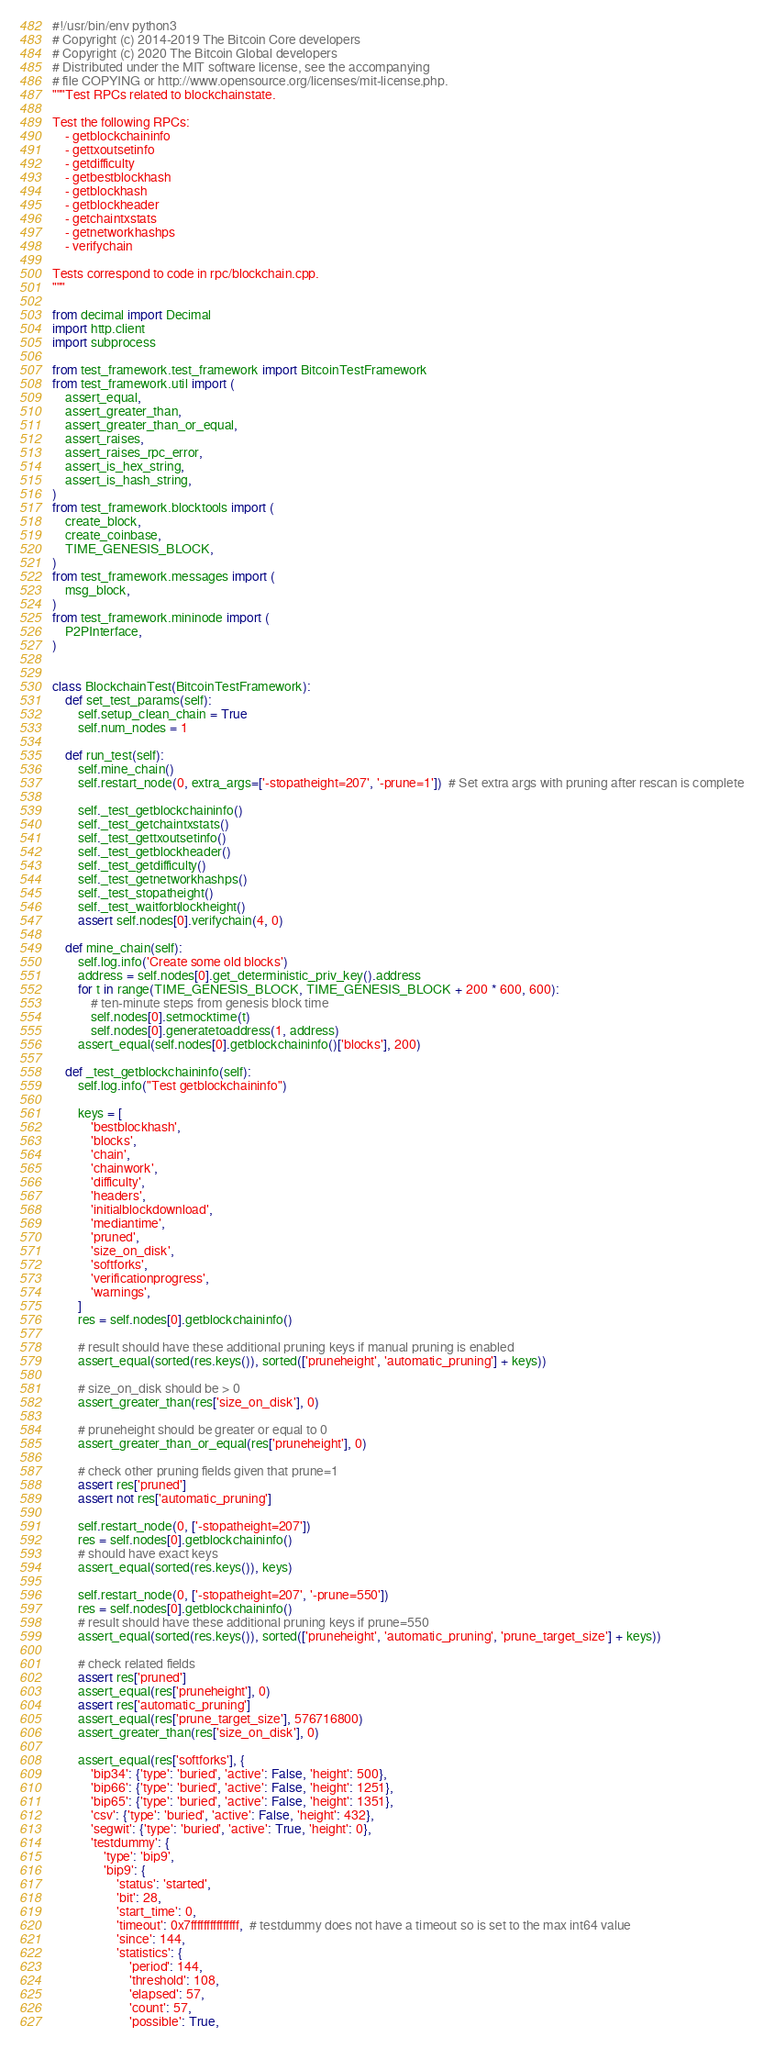<code> <loc_0><loc_0><loc_500><loc_500><_Python_>#!/usr/bin/env python3
# Copyright (c) 2014-2019 The Bitcoin Core developers
# Copyright (c) 2020 The Bitcoin Global developers
# Distributed under the MIT software license, see the accompanying
# file COPYING or http://www.opensource.org/licenses/mit-license.php.
"""Test RPCs related to blockchainstate.

Test the following RPCs:
    - getblockchaininfo
    - gettxoutsetinfo
    - getdifficulty
    - getbestblockhash
    - getblockhash
    - getblockheader
    - getchaintxstats
    - getnetworkhashps
    - verifychain

Tests correspond to code in rpc/blockchain.cpp.
"""

from decimal import Decimal
import http.client
import subprocess

from test_framework.test_framework import BitcoinTestFramework
from test_framework.util import (
    assert_equal,
    assert_greater_than,
    assert_greater_than_or_equal,
    assert_raises,
    assert_raises_rpc_error,
    assert_is_hex_string,
    assert_is_hash_string,
)
from test_framework.blocktools import (
    create_block,
    create_coinbase,
    TIME_GENESIS_BLOCK,
)
from test_framework.messages import (
    msg_block,
)
from test_framework.mininode import (
    P2PInterface,
)


class BlockchainTest(BitcoinTestFramework):
    def set_test_params(self):
        self.setup_clean_chain = True
        self.num_nodes = 1

    def run_test(self):
        self.mine_chain()
        self.restart_node(0, extra_args=['-stopatheight=207', '-prune=1'])  # Set extra args with pruning after rescan is complete

        self._test_getblockchaininfo()
        self._test_getchaintxstats()
        self._test_gettxoutsetinfo()
        self._test_getblockheader()
        self._test_getdifficulty()
        self._test_getnetworkhashps()
        self._test_stopatheight()
        self._test_waitforblockheight()
        assert self.nodes[0].verifychain(4, 0)

    def mine_chain(self):
        self.log.info('Create some old blocks')
        address = self.nodes[0].get_deterministic_priv_key().address
        for t in range(TIME_GENESIS_BLOCK, TIME_GENESIS_BLOCK + 200 * 600, 600):
            # ten-minute steps from genesis block time
            self.nodes[0].setmocktime(t)
            self.nodes[0].generatetoaddress(1, address)
        assert_equal(self.nodes[0].getblockchaininfo()['blocks'], 200)

    def _test_getblockchaininfo(self):
        self.log.info("Test getblockchaininfo")

        keys = [
            'bestblockhash',
            'blocks',
            'chain',
            'chainwork',
            'difficulty',
            'headers',
            'initialblockdownload',
            'mediantime',
            'pruned',
            'size_on_disk',
            'softforks',
            'verificationprogress',
            'warnings',
        ]
        res = self.nodes[0].getblockchaininfo()

        # result should have these additional pruning keys if manual pruning is enabled
        assert_equal(sorted(res.keys()), sorted(['pruneheight', 'automatic_pruning'] + keys))

        # size_on_disk should be > 0
        assert_greater_than(res['size_on_disk'], 0)

        # pruneheight should be greater or equal to 0
        assert_greater_than_or_equal(res['pruneheight'], 0)

        # check other pruning fields given that prune=1
        assert res['pruned']
        assert not res['automatic_pruning']

        self.restart_node(0, ['-stopatheight=207'])
        res = self.nodes[0].getblockchaininfo()
        # should have exact keys
        assert_equal(sorted(res.keys()), keys)

        self.restart_node(0, ['-stopatheight=207', '-prune=550'])
        res = self.nodes[0].getblockchaininfo()
        # result should have these additional pruning keys if prune=550
        assert_equal(sorted(res.keys()), sorted(['pruneheight', 'automatic_pruning', 'prune_target_size'] + keys))

        # check related fields
        assert res['pruned']
        assert_equal(res['pruneheight'], 0)
        assert res['automatic_pruning']
        assert_equal(res['prune_target_size'], 576716800)
        assert_greater_than(res['size_on_disk'], 0)

        assert_equal(res['softforks'], {
            'bip34': {'type': 'buried', 'active': False, 'height': 500},
            'bip66': {'type': 'buried', 'active': False, 'height': 1251},
            'bip65': {'type': 'buried', 'active': False, 'height': 1351},
            'csv': {'type': 'buried', 'active': False, 'height': 432},
            'segwit': {'type': 'buried', 'active': True, 'height': 0},
            'testdummy': {
                'type': 'bip9',
                'bip9': {
                    'status': 'started',
                    'bit': 28,
                    'start_time': 0,
                    'timeout': 0x7fffffffffffffff,  # testdummy does not have a timeout so is set to the max int64 value
                    'since': 144,
                    'statistics': {
                        'period': 144,
                        'threshold': 108,
                        'elapsed': 57,
                        'count': 57,
                        'possible': True,</code> 